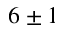Convert formula to latex. <formula><loc_0><loc_0><loc_500><loc_500>6 \pm 1</formula> 